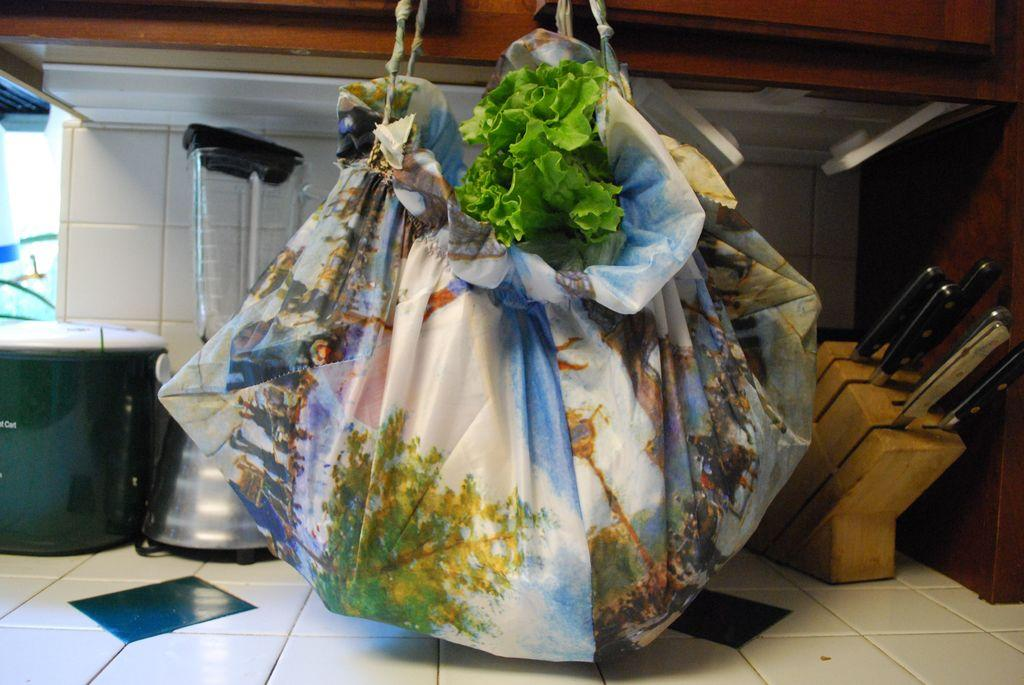What kitchen appliance is present with a glass jar in the image? There is a blender with a glass jar in the image. What type of utensils are stored in the image? There is a knife stand with knives in the image. What cooking appliance is visible in the image? There is a rice cooker in the image. What type of container is present in the image? There is a bag in the image. What natural element is present in the image? There are leaves in the image. What type of furniture is on the counter top in the image? There is a cupboard on the counter top in the image. How does the crow interact with the rice cooker in the image? There is no crow present in the image, so it cannot interact with the rice cooker. What type of self-care products are visible in the image? There is no reference to self-care products in the image; it features kitchen appliances and utensils. 